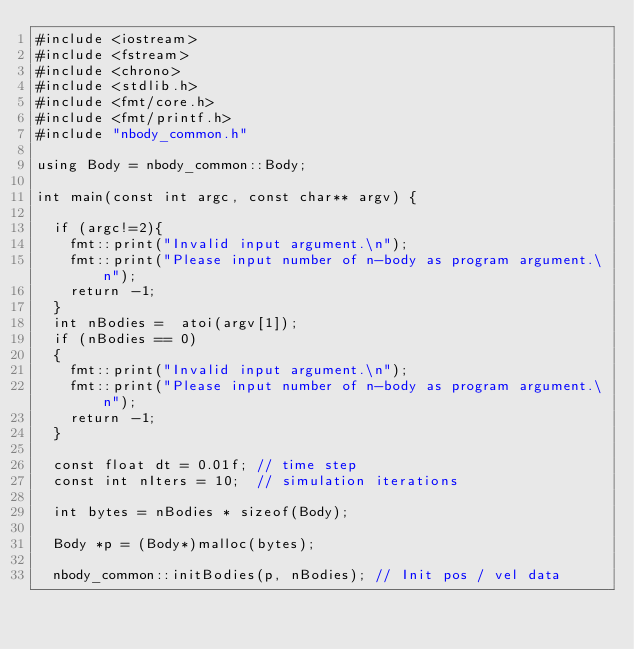<code> <loc_0><loc_0><loc_500><loc_500><_Cuda_>#include <iostream>
#include <fstream>
#include <chrono>
#include <stdlib.h> 
#include <fmt/core.h>
#include <fmt/printf.h>
#include "nbody_common.h"

using Body = nbody_common::Body;

int main(const int argc, const char** argv) {

  if (argc!=2){
    fmt::print("Invalid input argument.\n");
    fmt::print("Please input number of n-body as program argument.\n");
    return -1;
  }  
  int nBodies =  atoi(argv[1]);
  if (nBodies == 0)
  {
    fmt::print("Invalid input argument.\n");
    fmt::print("Please input number of n-body as program argument.\n");
    return -1;
  }  

  const float dt = 0.01f; // time step
  const int nIters = 10;  // simulation iterations

  int bytes = nBodies * sizeof(Body);

  Body *p = (Body*)malloc(bytes);

  nbody_common::initBodies(p, nBodies); // Init pos / vel data</code> 